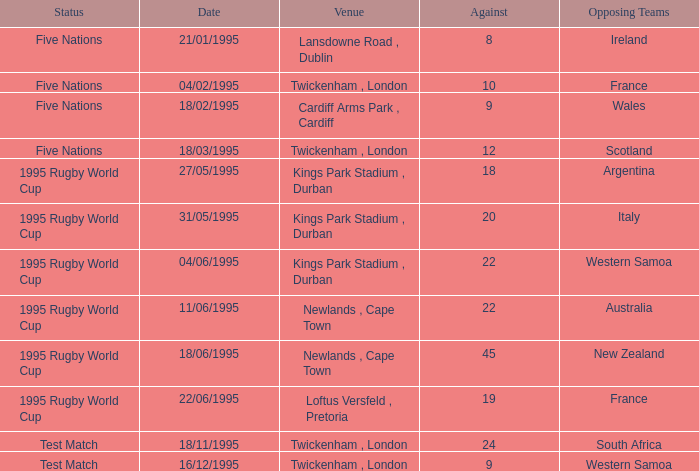What's the total against for opposing team scotland at twickenham, london venue with a status of five nations? 1.0. 